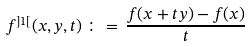<formula> <loc_0><loc_0><loc_500><loc_500>f ^ { ] 1 [ } ( x , y , t ) \, \colon = \, \frac { f ( x + t y ) - f ( x ) } { t }</formula> 